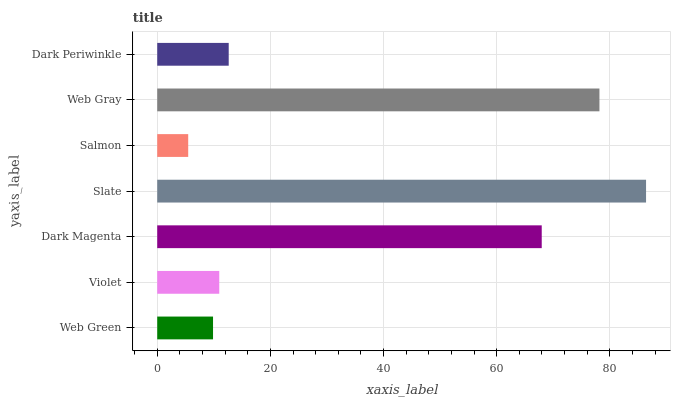Is Salmon the minimum?
Answer yes or no. Yes. Is Slate the maximum?
Answer yes or no. Yes. Is Violet the minimum?
Answer yes or no. No. Is Violet the maximum?
Answer yes or no. No. Is Violet greater than Web Green?
Answer yes or no. Yes. Is Web Green less than Violet?
Answer yes or no. Yes. Is Web Green greater than Violet?
Answer yes or no. No. Is Violet less than Web Green?
Answer yes or no. No. Is Dark Periwinkle the high median?
Answer yes or no. Yes. Is Dark Periwinkle the low median?
Answer yes or no. Yes. Is Salmon the high median?
Answer yes or no. No. Is Salmon the low median?
Answer yes or no. No. 